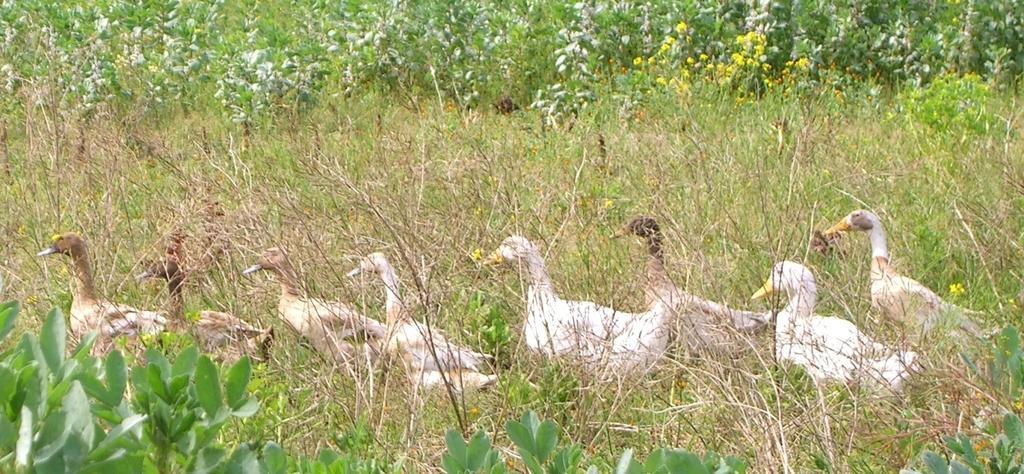Can you describe this image briefly? In this picture we can see ducks, there are some plants at the bottom, in the background we can see some flowers and trees. 